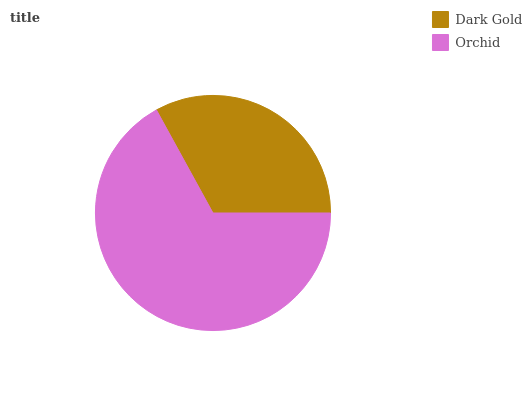Is Dark Gold the minimum?
Answer yes or no. Yes. Is Orchid the maximum?
Answer yes or no. Yes. Is Orchid the minimum?
Answer yes or no. No. Is Orchid greater than Dark Gold?
Answer yes or no. Yes. Is Dark Gold less than Orchid?
Answer yes or no. Yes. Is Dark Gold greater than Orchid?
Answer yes or no. No. Is Orchid less than Dark Gold?
Answer yes or no. No. Is Orchid the high median?
Answer yes or no. Yes. Is Dark Gold the low median?
Answer yes or no. Yes. Is Dark Gold the high median?
Answer yes or no. No. Is Orchid the low median?
Answer yes or no. No. 